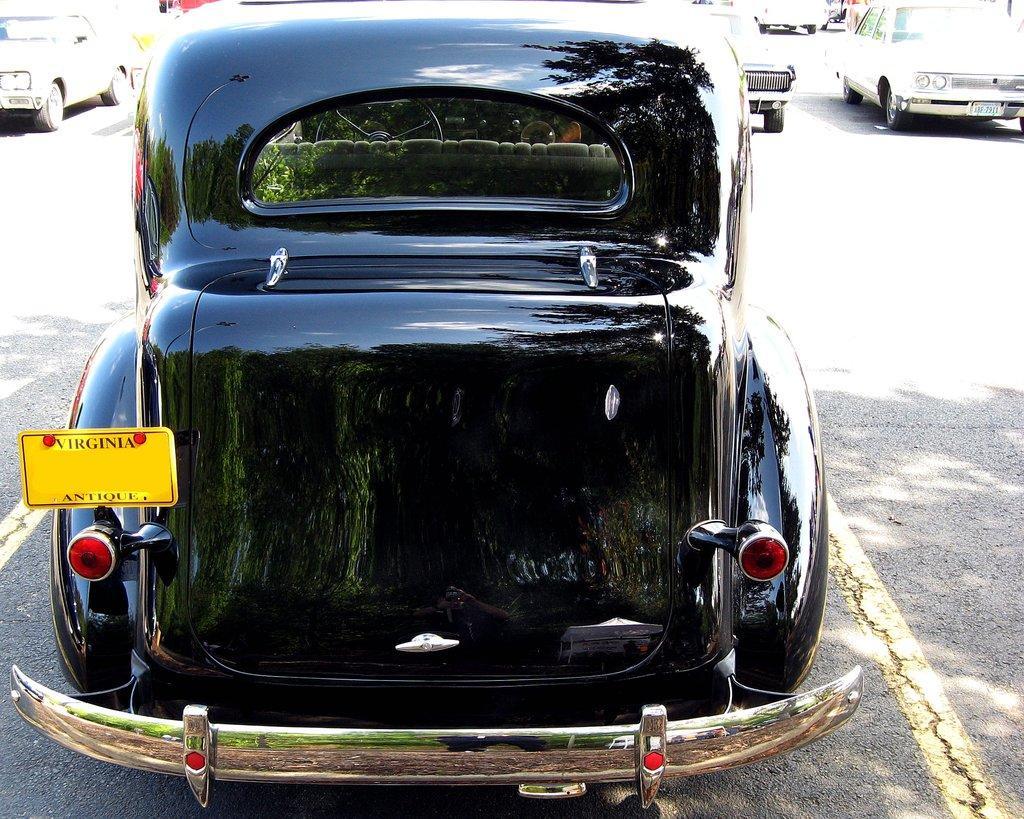Describe this image in one or two sentences. In this picture we can see a black car on the road and in the background we can see some vehicles. 